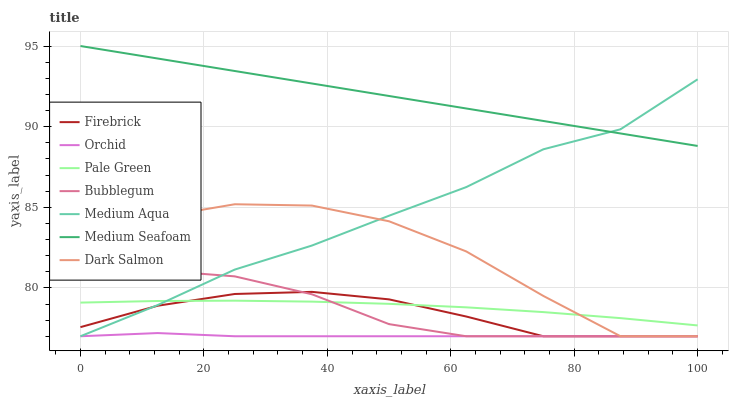Does Dark Salmon have the minimum area under the curve?
Answer yes or no. No. Does Dark Salmon have the maximum area under the curve?
Answer yes or no. No. Is Bubblegum the smoothest?
Answer yes or no. No. Is Bubblegum the roughest?
Answer yes or no. No. Does Pale Green have the lowest value?
Answer yes or no. No. Does Dark Salmon have the highest value?
Answer yes or no. No. Is Bubblegum less than Medium Seafoam?
Answer yes or no. Yes. Is Medium Seafoam greater than Pale Green?
Answer yes or no. Yes. Does Bubblegum intersect Medium Seafoam?
Answer yes or no. No. 